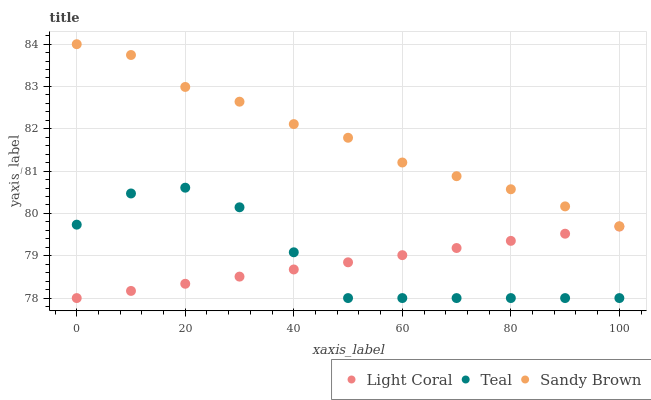Does Light Coral have the minimum area under the curve?
Answer yes or no. Yes. Does Sandy Brown have the maximum area under the curve?
Answer yes or no. Yes. Does Teal have the minimum area under the curve?
Answer yes or no. No. Does Teal have the maximum area under the curve?
Answer yes or no. No. Is Light Coral the smoothest?
Answer yes or no. Yes. Is Teal the roughest?
Answer yes or no. Yes. Is Sandy Brown the smoothest?
Answer yes or no. No. Is Sandy Brown the roughest?
Answer yes or no. No. Does Light Coral have the lowest value?
Answer yes or no. Yes. Does Sandy Brown have the lowest value?
Answer yes or no. No. Does Sandy Brown have the highest value?
Answer yes or no. Yes. Does Teal have the highest value?
Answer yes or no. No. Is Light Coral less than Sandy Brown?
Answer yes or no. Yes. Is Sandy Brown greater than Light Coral?
Answer yes or no. Yes. Does Teal intersect Light Coral?
Answer yes or no. Yes. Is Teal less than Light Coral?
Answer yes or no. No. Is Teal greater than Light Coral?
Answer yes or no. No. Does Light Coral intersect Sandy Brown?
Answer yes or no. No. 